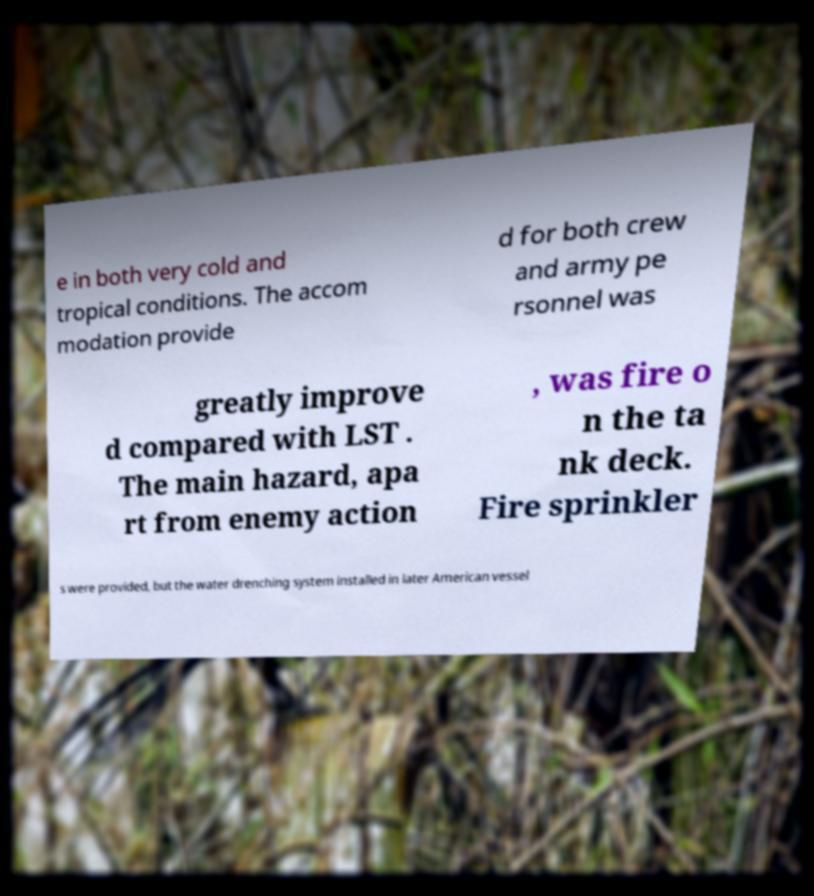For documentation purposes, I need the text within this image transcribed. Could you provide that? e in both very cold and tropical conditions. The accom modation provide d for both crew and army pe rsonnel was greatly improve d compared with LST . The main hazard, apa rt from enemy action , was fire o n the ta nk deck. Fire sprinkler s were provided, but the water drenching system installed in later American vessel 